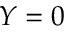Convert formula to latex. <formula><loc_0><loc_0><loc_500><loc_500>Y = 0</formula> 